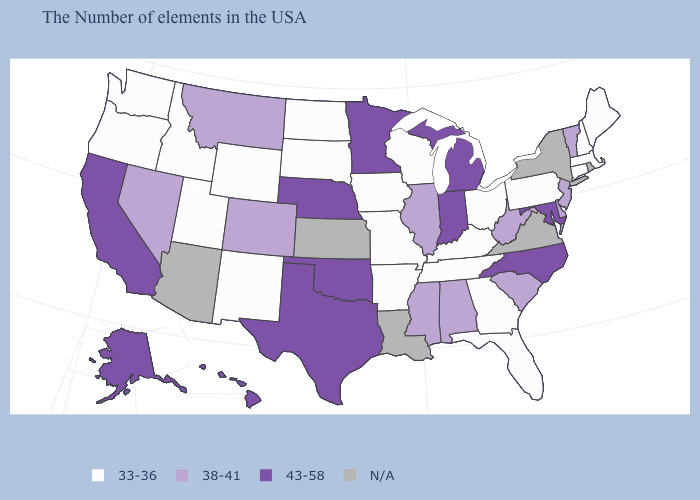What is the highest value in the USA?
Write a very short answer. 43-58. Among the states that border Wisconsin , does Minnesota have the highest value?
Answer briefly. Yes. Name the states that have a value in the range 33-36?
Give a very brief answer. Maine, Massachusetts, New Hampshire, Connecticut, Pennsylvania, Ohio, Florida, Georgia, Kentucky, Tennessee, Wisconsin, Missouri, Arkansas, Iowa, South Dakota, North Dakota, Wyoming, New Mexico, Utah, Idaho, Washington, Oregon. Name the states that have a value in the range 38-41?
Write a very short answer. Vermont, New Jersey, Delaware, South Carolina, West Virginia, Alabama, Illinois, Mississippi, Colorado, Montana, Nevada. Name the states that have a value in the range 43-58?
Be succinct. Maryland, North Carolina, Michigan, Indiana, Minnesota, Nebraska, Oklahoma, Texas, California, Alaska, Hawaii. How many symbols are there in the legend?
Be succinct. 4. Name the states that have a value in the range N/A?
Write a very short answer. Rhode Island, New York, Virginia, Louisiana, Kansas, Arizona. What is the lowest value in the Northeast?
Give a very brief answer. 33-36. Which states have the highest value in the USA?
Concise answer only. Maryland, North Carolina, Michigan, Indiana, Minnesota, Nebraska, Oklahoma, Texas, California, Alaska, Hawaii. Which states have the lowest value in the USA?
Concise answer only. Maine, Massachusetts, New Hampshire, Connecticut, Pennsylvania, Ohio, Florida, Georgia, Kentucky, Tennessee, Wisconsin, Missouri, Arkansas, Iowa, South Dakota, North Dakota, Wyoming, New Mexico, Utah, Idaho, Washington, Oregon. What is the value of South Carolina?
Answer briefly. 38-41. Name the states that have a value in the range 33-36?
Concise answer only. Maine, Massachusetts, New Hampshire, Connecticut, Pennsylvania, Ohio, Florida, Georgia, Kentucky, Tennessee, Wisconsin, Missouri, Arkansas, Iowa, South Dakota, North Dakota, Wyoming, New Mexico, Utah, Idaho, Washington, Oregon. 